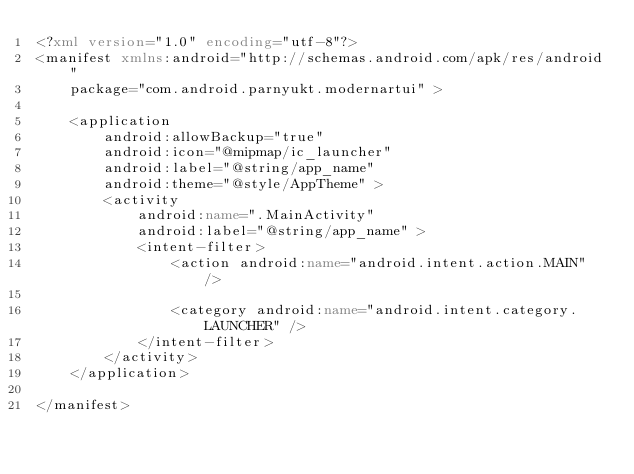Convert code to text. <code><loc_0><loc_0><loc_500><loc_500><_XML_><?xml version="1.0" encoding="utf-8"?>
<manifest xmlns:android="http://schemas.android.com/apk/res/android"
    package="com.android.parnyukt.modernartui" >

    <application
        android:allowBackup="true"
        android:icon="@mipmap/ic_launcher"
        android:label="@string/app_name"
        android:theme="@style/AppTheme" >
        <activity
            android:name=".MainActivity"
            android:label="@string/app_name" >
            <intent-filter>
                <action android:name="android.intent.action.MAIN" />

                <category android:name="android.intent.category.LAUNCHER" />
            </intent-filter>
        </activity>
    </application>

</manifest>
</code> 